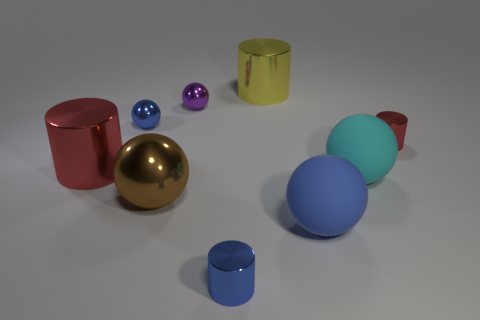Subtract all brown balls. How many red cylinders are left? 2 Subtract all brown spheres. How many spheres are left? 4 Subtract all large blue rubber spheres. How many spheres are left? 4 Subtract all cyan cylinders. Subtract all yellow balls. How many cylinders are left? 4 Add 1 blue matte things. How many objects exist? 10 Subtract all cylinders. How many objects are left? 5 Subtract 0 brown cylinders. How many objects are left? 9 Subtract all small purple cylinders. Subtract all rubber balls. How many objects are left? 7 Add 3 small purple spheres. How many small purple spheres are left? 4 Add 3 big red things. How many big red things exist? 4 